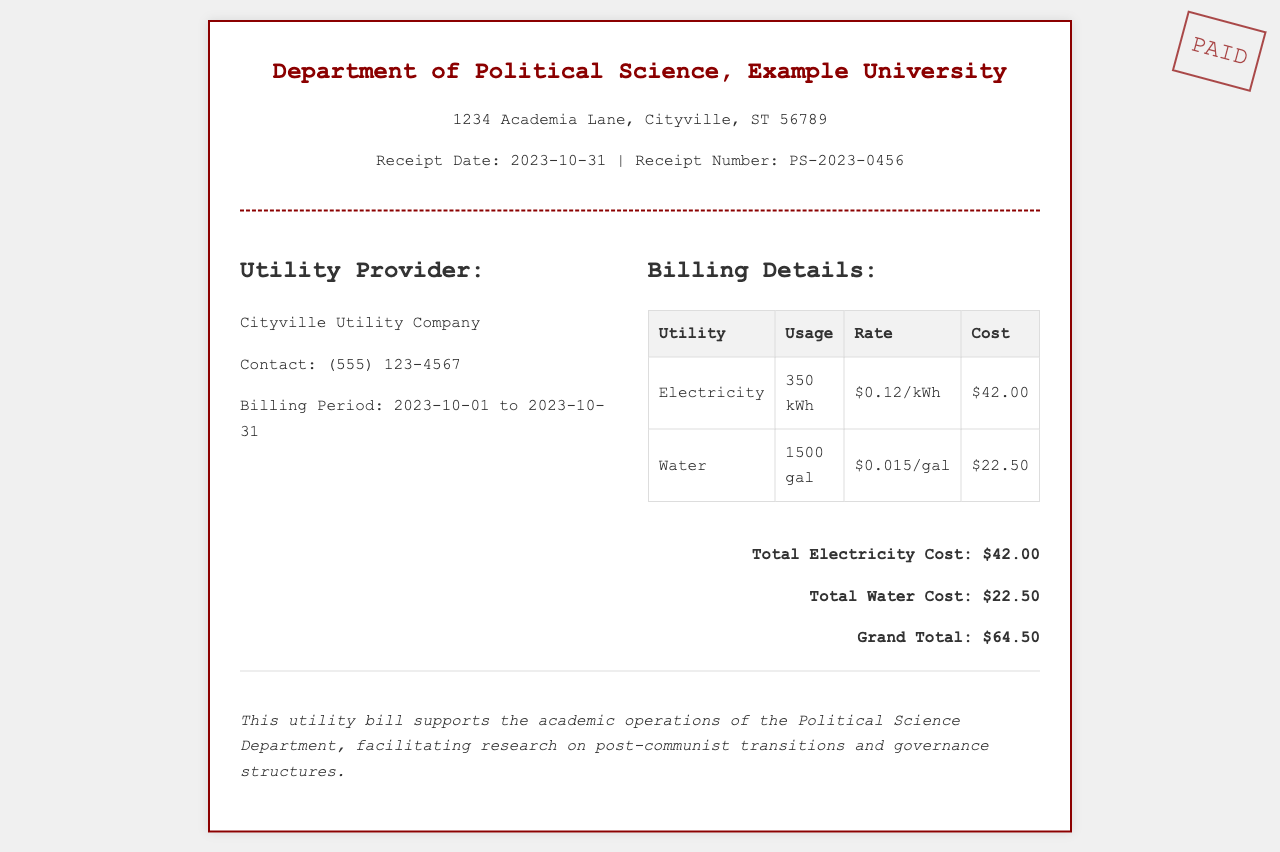what is the receipt date? The receipt date is specified in the header section of the document as 2023-10-31.
Answer: 2023-10-31 who is the utility provider? The utility provider name can be found in the billing details section where it states Cityville Utility Company.
Answer: Cityville Utility Company what is the total cost of electricity? The total cost of electricity is provided in the billing details section as $42.00.
Answer: $42.00 how much water was used? The amount of water usage is stated in the document as 1500 gallons.
Answer: 1500 gal what is the grand total for the utility bill? The grand total is calculated from the sum of the electricity and water costs in the total section, which amounts to $64.50.
Answer: $64.50 what is the contact number for the utility provider? The contact number is listed in the utility provider section as (555) 123-4567.
Answer: (555) 123-4567 what is the billing period? The billing period is indicated in the document as 2023-10-01 to 2023-10-31.
Answer: 2023-10-01 to 2023-10-31 what is the rate for water usage? The rate for water usage is shown in the billing details table as $0.015 per gallon.
Answer: $0.015/gal what department is this receipt for? The department name is mentioned in the header of the document as Department of Political Science.
Answer: Department of Political Science 